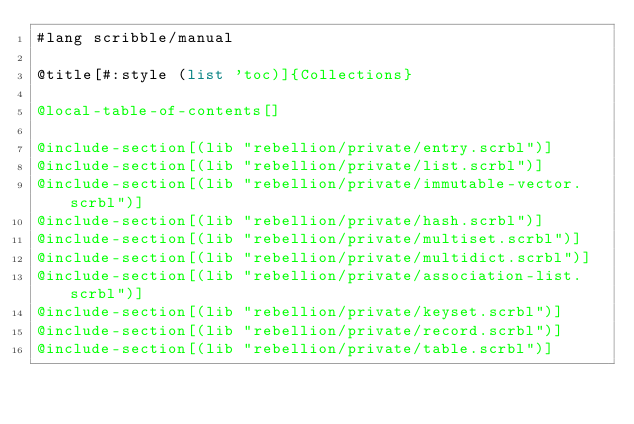Convert code to text. <code><loc_0><loc_0><loc_500><loc_500><_Racket_>#lang scribble/manual

@title[#:style (list 'toc)]{Collections}

@local-table-of-contents[]

@include-section[(lib "rebellion/private/entry.scrbl")]
@include-section[(lib "rebellion/private/list.scrbl")]
@include-section[(lib "rebellion/private/immutable-vector.scrbl")]
@include-section[(lib "rebellion/private/hash.scrbl")]
@include-section[(lib "rebellion/private/multiset.scrbl")]
@include-section[(lib "rebellion/private/multidict.scrbl")]
@include-section[(lib "rebellion/private/association-list.scrbl")]
@include-section[(lib "rebellion/private/keyset.scrbl")]
@include-section[(lib "rebellion/private/record.scrbl")]
@include-section[(lib "rebellion/private/table.scrbl")]
</code> 